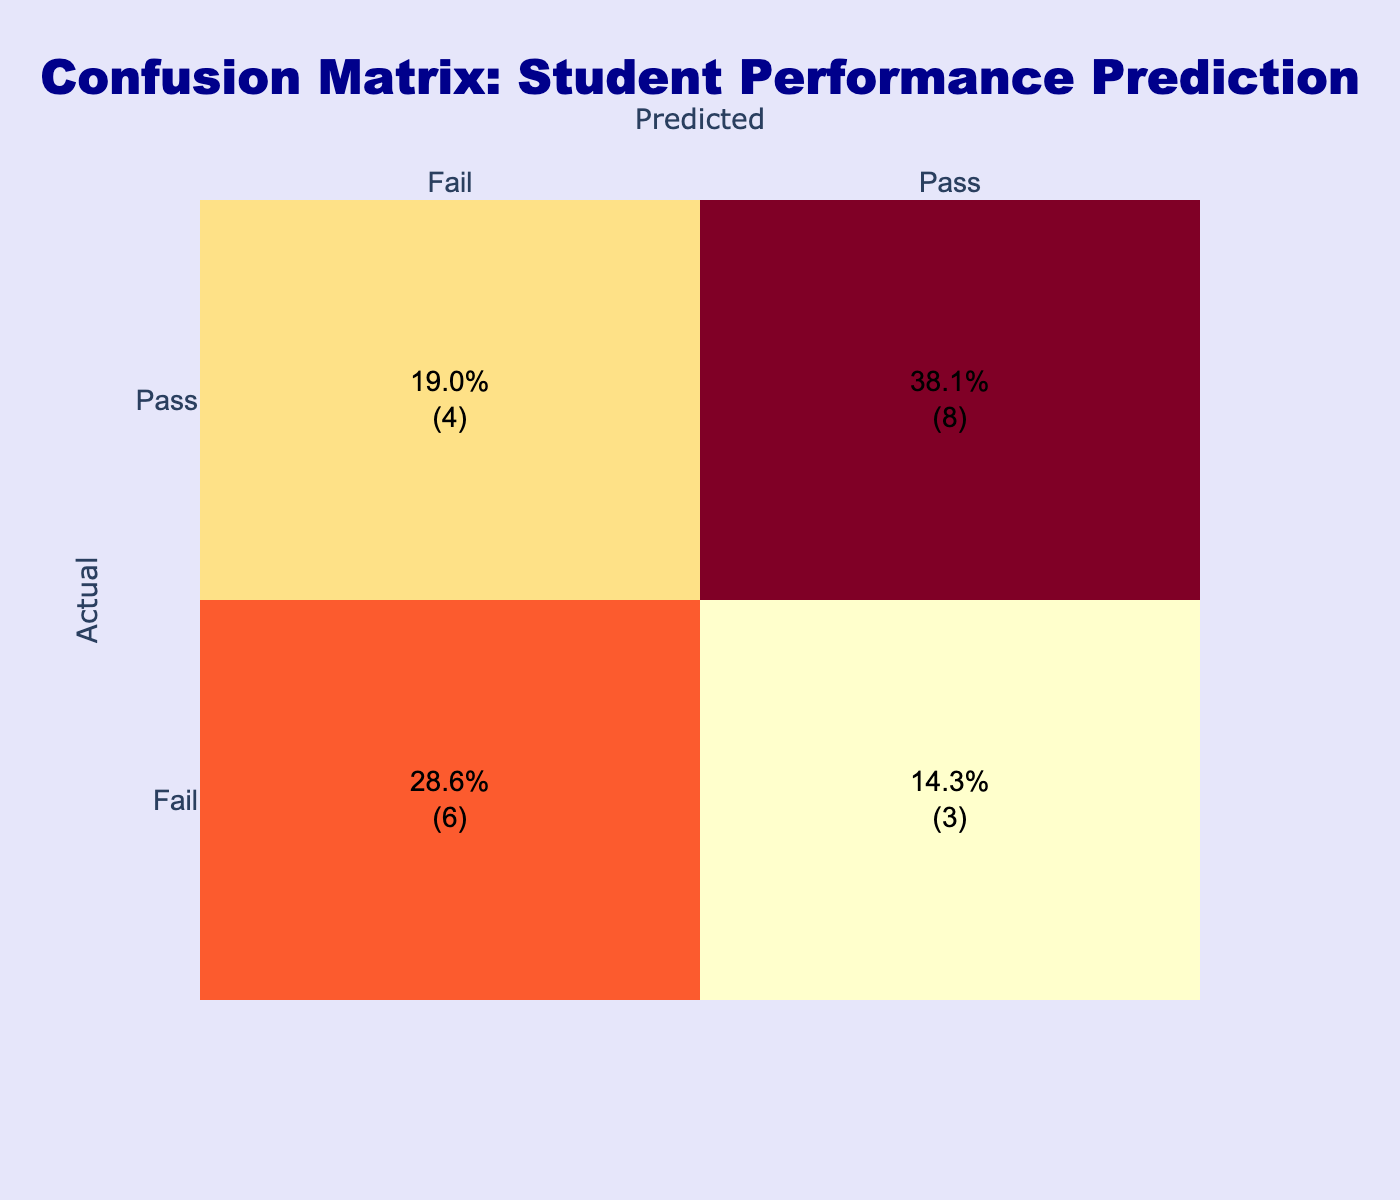What is the total number of students predicted to Pass? To find the total number of students predicted to Pass, we need to look at the "Predicted" column for each entry that says "Pass." Counting those entries, we find there are 7 instances where the predicted outcome is Pass.
Answer: 7 What is the total number of students who actually failed? We check the "Actual" column for entries labeled "Fail." Counting those, we find there are 7 instances where the actual outcome is Fail.
Answer: 7 How many students were predicted to Fail but actually Passed? We need to identify the entries where the predicted outcome is "Fail" while the actual outcome is "Pass." There are 3 such instances when combining the observations in the table.
Answer: 3 What is the percentage of students that were correctly predicted to Pass? The total number of correct predictions for Pass is the count of instances where both actual and predicted outcomes are Pass, which is 5. The total number of predictions is 20 (the sum of all instances). Therefore, the percentage is (5/20) * 100 = 25%.
Answer: 25% Is the number of students who actually passed more than those who actually failed? To answer this, we compare the counts: 13 students passed (counting `"Pass"` from Actual) and 7 students failed (counting `"Fail"` from Actual). Since 13 is greater than 7, the statement is true.
Answer: Yes What is the total number of misclassifications in predicted outcomes? Misclassifications occur when the predicted outcome does not match the actual outcome. In this case, we found 5 instances: (3 predicted Fail when they passed and 2 predicted Pass when they failed). Thus, the total number of misclassifications is 5.
Answer: 5 What is the ratio of students who were correctly predicted to fail to those who were misclassified? We find that the number of students predicted correctly to fail is 5 and the number of misclassifications is also 5. The ratio is therefore 5 to 5, which simplifies to 1 to 1.
Answer: 1:1 How many times did the model predict Fail when the actual outcome was Pass? We look for instances where the actual outcome is "Pass" and the predicted outcome is "Fail." There are 3 instances where this occurs, indicating that the model incorrectly predicted Fail for students who actually passed.
Answer: 3 What percentage of all predicted outcomes were correctly predicted overall? To calculate the overall accuracy, we need to consider both correct predictions of Pass (5) and Fail (5), which gives us a total of 10 correct predictions out of 20 total predictions. Therefore, the percentage is (10/20) * 100 = 50%.
Answer: 50% 